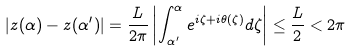Convert formula to latex. <formula><loc_0><loc_0><loc_500><loc_500>\left | z ( \alpha ) - z ( \alpha ^ { \prime } ) \right | = \frac { L } { 2 \pi } \left | \int _ { \alpha ^ { \prime } } ^ { \alpha } e ^ { i \zeta + i \theta ( \zeta ) } d \zeta \right | \leq \frac { L } { 2 } < 2 \pi</formula> 